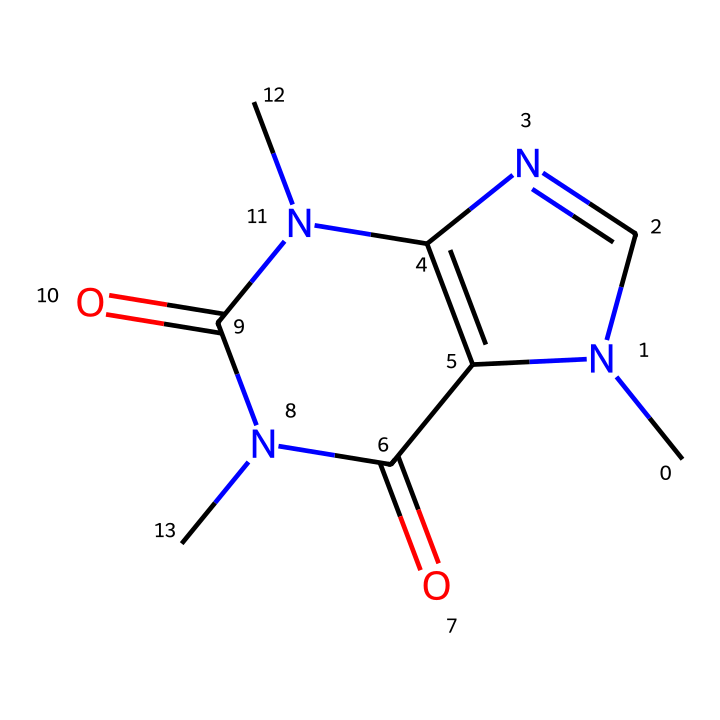How many nitrogen atoms are present in the structure? By examining the SMILES representation, we can identify that there are two distinct nitrogen atoms indicated by the "N" symbols in the structure.
Answer: 2 What type of bonds connect the carbon atoms? The SMILES representation shows multiple carbon atoms connected directly, indicating covalent bonding, which is the typical bond type between carbon atoms in organic compounds.
Answer: covalent Identify the functional groups present in caffeine Analyzing the structure, we can identify two carbonyl groups (C=O) due to the presence of the "=" sign attached to carbon atoms, alongside nitrogen contributions indicative of amine groups as well.
Answer: amine and carbonyl What is the molecular formula of caffeine? To determine the molecular formula, we count the number of each type of atom present in the structure defined by the SMILES: C is 8, H is 10, N is 4, O is 2, leading to the formula C8H10N4O2.
Answer: C8H10N4O2 What is the role of the nitrogen atoms in caffeine? The nitrogen atoms in caffeine contribute basic properties due to their lone pairs of electrons, which can form hydrogen bonds and impact the compound's interaction with receptors in the body, contributing to its stimulant effects.
Answer: basic properties Is caffeine classified as a stimulant? Yes, based on its chemical structure, particularly its interactions with adenosine receptors, caffeine is well-recognized for its stimulant properties, enhancing alertness and reducing fatigue.
Answer: yes 